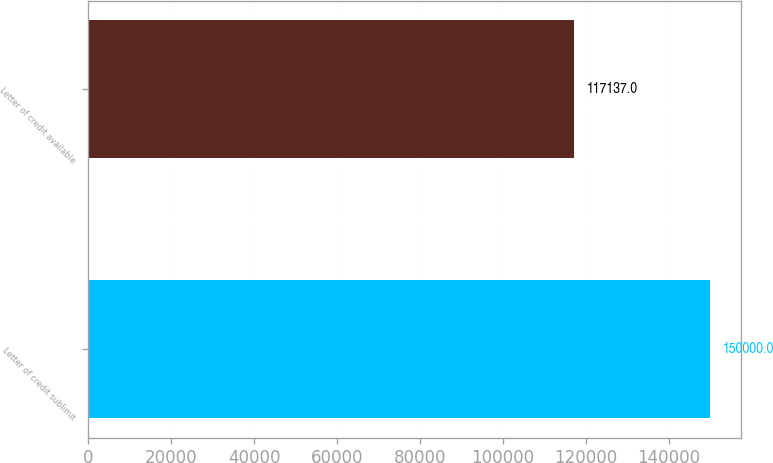<chart> <loc_0><loc_0><loc_500><loc_500><bar_chart><fcel>Letter of credit sublimit<fcel>Letter of credit available<nl><fcel>150000<fcel>117137<nl></chart> 